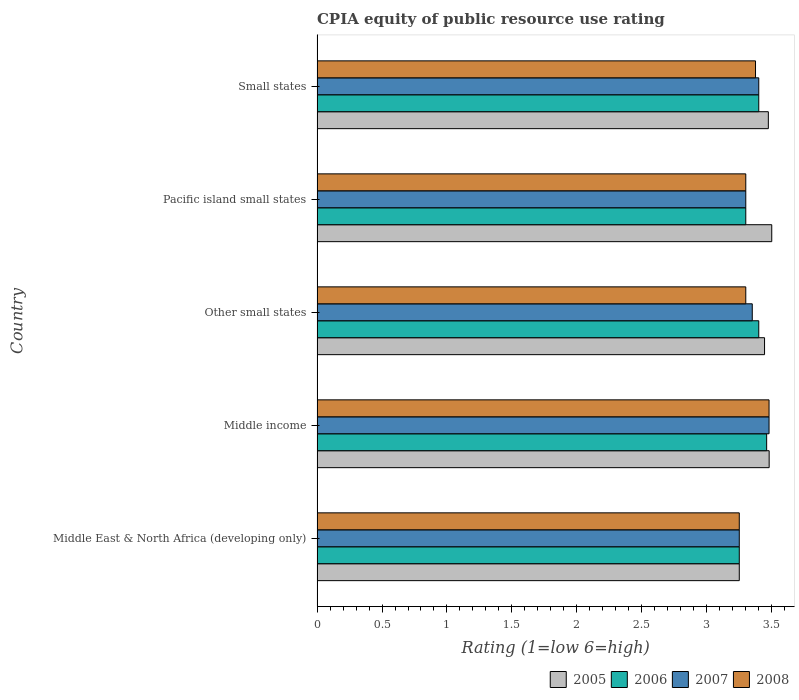Are the number of bars per tick equal to the number of legend labels?
Your answer should be compact. Yes. Are the number of bars on each tick of the Y-axis equal?
Offer a very short reply. Yes. What is the label of the 4th group of bars from the top?
Provide a short and direct response. Middle income. In how many cases, is the number of bars for a given country not equal to the number of legend labels?
Give a very brief answer. 0. What is the CPIA rating in 2007 in Small states?
Your answer should be very brief. 3.4. Across all countries, what is the maximum CPIA rating in 2007?
Provide a short and direct response. 3.48. In which country was the CPIA rating in 2005 maximum?
Your answer should be very brief. Pacific island small states. In which country was the CPIA rating in 2006 minimum?
Your answer should be very brief. Middle East & North Africa (developing only). What is the total CPIA rating in 2006 in the graph?
Give a very brief answer. 16.81. What is the difference between the CPIA rating in 2005 in Other small states and that in Small states?
Offer a very short reply. -0.03. What is the difference between the CPIA rating in 2008 in Pacific island small states and the CPIA rating in 2005 in Small states?
Give a very brief answer. -0.17. What is the average CPIA rating in 2005 per country?
Make the answer very short. 3.43. What is the difference between the CPIA rating in 2007 and CPIA rating in 2008 in Other small states?
Make the answer very short. 0.05. What is the ratio of the CPIA rating in 2007 in Middle income to that in Pacific island small states?
Keep it short and to the point. 1.05. What is the difference between the highest and the second highest CPIA rating in 2008?
Your answer should be very brief. 0.1. What is the difference between the highest and the lowest CPIA rating in 2008?
Offer a terse response. 0.23. Is it the case that in every country, the sum of the CPIA rating in 2008 and CPIA rating in 2007 is greater than the sum of CPIA rating in 2005 and CPIA rating in 2006?
Make the answer very short. No. What does the 4th bar from the bottom in Middle East & North Africa (developing only) represents?
Offer a very short reply. 2008. Is it the case that in every country, the sum of the CPIA rating in 2005 and CPIA rating in 2008 is greater than the CPIA rating in 2007?
Provide a succinct answer. Yes. Are all the bars in the graph horizontal?
Your response must be concise. Yes. How many countries are there in the graph?
Offer a very short reply. 5. Are the values on the major ticks of X-axis written in scientific E-notation?
Give a very brief answer. No. Does the graph contain grids?
Offer a very short reply. No. What is the title of the graph?
Keep it short and to the point. CPIA equity of public resource use rating. What is the label or title of the X-axis?
Keep it short and to the point. Rating (1=low 6=high). What is the Rating (1=low 6=high) of 2007 in Middle East & North Africa (developing only)?
Your answer should be compact. 3.25. What is the Rating (1=low 6=high) in 2005 in Middle income?
Give a very brief answer. 3.48. What is the Rating (1=low 6=high) of 2006 in Middle income?
Provide a short and direct response. 3.46. What is the Rating (1=low 6=high) of 2007 in Middle income?
Make the answer very short. 3.48. What is the Rating (1=low 6=high) in 2008 in Middle income?
Ensure brevity in your answer.  3.48. What is the Rating (1=low 6=high) in 2005 in Other small states?
Offer a terse response. 3.44. What is the Rating (1=low 6=high) in 2006 in Other small states?
Provide a short and direct response. 3.4. What is the Rating (1=low 6=high) in 2007 in Other small states?
Your answer should be very brief. 3.35. What is the Rating (1=low 6=high) in 2005 in Pacific island small states?
Your answer should be compact. 3.5. What is the Rating (1=low 6=high) of 2007 in Pacific island small states?
Your answer should be very brief. 3.3. What is the Rating (1=low 6=high) of 2008 in Pacific island small states?
Your response must be concise. 3.3. What is the Rating (1=low 6=high) of 2005 in Small states?
Provide a short and direct response. 3.47. What is the Rating (1=low 6=high) of 2006 in Small states?
Offer a very short reply. 3.4. What is the Rating (1=low 6=high) of 2008 in Small states?
Provide a succinct answer. 3.38. Across all countries, what is the maximum Rating (1=low 6=high) of 2006?
Your response must be concise. 3.46. Across all countries, what is the maximum Rating (1=low 6=high) in 2007?
Your answer should be compact. 3.48. Across all countries, what is the maximum Rating (1=low 6=high) of 2008?
Your answer should be compact. 3.48. Across all countries, what is the minimum Rating (1=low 6=high) of 2007?
Give a very brief answer. 3.25. Across all countries, what is the minimum Rating (1=low 6=high) in 2008?
Make the answer very short. 3.25. What is the total Rating (1=low 6=high) in 2005 in the graph?
Provide a succinct answer. 17.15. What is the total Rating (1=low 6=high) of 2006 in the graph?
Give a very brief answer. 16.81. What is the total Rating (1=low 6=high) of 2007 in the graph?
Ensure brevity in your answer.  16.78. What is the total Rating (1=low 6=high) of 2008 in the graph?
Ensure brevity in your answer.  16.7. What is the difference between the Rating (1=low 6=high) of 2005 in Middle East & North Africa (developing only) and that in Middle income?
Keep it short and to the point. -0.23. What is the difference between the Rating (1=low 6=high) of 2006 in Middle East & North Africa (developing only) and that in Middle income?
Keep it short and to the point. -0.21. What is the difference between the Rating (1=low 6=high) in 2007 in Middle East & North Africa (developing only) and that in Middle income?
Make the answer very short. -0.23. What is the difference between the Rating (1=low 6=high) of 2008 in Middle East & North Africa (developing only) and that in Middle income?
Make the answer very short. -0.23. What is the difference between the Rating (1=low 6=high) of 2005 in Middle East & North Africa (developing only) and that in Other small states?
Make the answer very short. -0.19. What is the difference between the Rating (1=low 6=high) of 2006 in Middle East & North Africa (developing only) and that in Other small states?
Make the answer very short. -0.15. What is the difference between the Rating (1=low 6=high) of 2008 in Middle East & North Africa (developing only) and that in Other small states?
Your response must be concise. -0.05. What is the difference between the Rating (1=low 6=high) in 2008 in Middle East & North Africa (developing only) and that in Pacific island small states?
Provide a short and direct response. -0.05. What is the difference between the Rating (1=low 6=high) of 2005 in Middle East & North Africa (developing only) and that in Small states?
Your response must be concise. -0.22. What is the difference between the Rating (1=low 6=high) in 2006 in Middle East & North Africa (developing only) and that in Small states?
Your answer should be very brief. -0.15. What is the difference between the Rating (1=low 6=high) of 2007 in Middle East & North Africa (developing only) and that in Small states?
Give a very brief answer. -0.15. What is the difference between the Rating (1=low 6=high) in 2008 in Middle East & North Africa (developing only) and that in Small states?
Provide a succinct answer. -0.12. What is the difference between the Rating (1=low 6=high) in 2005 in Middle income and that in Other small states?
Offer a terse response. 0.04. What is the difference between the Rating (1=low 6=high) of 2006 in Middle income and that in Other small states?
Make the answer very short. 0.06. What is the difference between the Rating (1=low 6=high) in 2007 in Middle income and that in Other small states?
Your answer should be very brief. 0.13. What is the difference between the Rating (1=low 6=high) in 2008 in Middle income and that in Other small states?
Keep it short and to the point. 0.18. What is the difference between the Rating (1=low 6=high) of 2005 in Middle income and that in Pacific island small states?
Your response must be concise. -0.02. What is the difference between the Rating (1=low 6=high) in 2006 in Middle income and that in Pacific island small states?
Your response must be concise. 0.16. What is the difference between the Rating (1=low 6=high) of 2007 in Middle income and that in Pacific island small states?
Give a very brief answer. 0.18. What is the difference between the Rating (1=low 6=high) of 2008 in Middle income and that in Pacific island small states?
Provide a short and direct response. 0.18. What is the difference between the Rating (1=low 6=high) in 2005 in Middle income and that in Small states?
Your answer should be compact. 0.01. What is the difference between the Rating (1=low 6=high) in 2006 in Middle income and that in Small states?
Provide a short and direct response. 0.06. What is the difference between the Rating (1=low 6=high) in 2007 in Middle income and that in Small states?
Your response must be concise. 0.08. What is the difference between the Rating (1=low 6=high) of 2008 in Middle income and that in Small states?
Your answer should be compact. 0.1. What is the difference between the Rating (1=low 6=high) of 2005 in Other small states and that in Pacific island small states?
Keep it short and to the point. -0.06. What is the difference between the Rating (1=low 6=high) of 2007 in Other small states and that in Pacific island small states?
Keep it short and to the point. 0.05. What is the difference between the Rating (1=low 6=high) in 2005 in Other small states and that in Small states?
Give a very brief answer. -0.03. What is the difference between the Rating (1=low 6=high) of 2006 in Other small states and that in Small states?
Keep it short and to the point. 0. What is the difference between the Rating (1=low 6=high) of 2008 in Other small states and that in Small states?
Keep it short and to the point. -0.07. What is the difference between the Rating (1=low 6=high) in 2005 in Pacific island small states and that in Small states?
Offer a very short reply. 0.03. What is the difference between the Rating (1=low 6=high) in 2006 in Pacific island small states and that in Small states?
Keep it short and to the point. -0.1. What is the difference between the Rating (1=low 6=high) of 2008 in Pacific island small states and that in Small states?
Offer a terse response. -0.07. What is the difference between the Rating (1=low 6=high) in 2005 in Middle East & North Africa (developing only) and the Rating (1=low 6=high) in 2006 in Middle income?
Provide a short and direct response. -0.21. What is the difference between the Rating (1=low 6=high) of 2005 in Middle East & North Africa (developing only) and the Rating (1=low 6=high) of 2007 in Middle income?
Provide a succinct answer. -0.23. What is the difference between the Rating (1=low 6=high) of 2005 in Middle East & North Africa (developing only) and the Rating (1=low 6=high) of 2008 in Middle income?
Your answer should be very brief. -0.23. What is the difference between the Rating (1=low 6=high) in 2006 in Middle East & North Africa (developing only) and the Rating (1=low 6=high) in 2007 in Middle income?
Your answer should be compact. -0.23. What is the difference between the Rating (1=low 6=high) of 2006 in Middle East & North Africa (developing only) and the Rating (1=low 6=high) of 2008 in Middle income?
Your answer should be compact. -0.23. What is the difference between the Rating (1=low 6=high) of 2007 in Middle East & North Africa (developing only) and the Rating (1=low 6=high) of 2008 in Middle income?
Your answer should be very brief. -0.23. What is the difference between the Rating (1=low 6=high) in 2005 in Middle East & North Africa (developing only) and the Rating (1=low 6=high) in 2007 in Other small states?
Give a very brief answer. -0.1. What is the difference between the Rating (1=low 6=high) of 2005 in Middle East & North Africa (developing only) and the Rating (1=low 6=high) of 2008 in Other small states?
Your response must be concise. -0.05. What is the difference between the Rating (1=low 6=high) of 2006 in Middle East & North Africa (developing only) and the Rating (1=low 6=high) of 2008 in Other small states?
Give a very brief answer. -0.05. What is the difference between the Rating (1=low 6=high) of 2007 in Middle East & North Africa (developing only) and the Rating (1=low 6=high) of 2008 in Other small states?
Your response must be concise. -0.05. What is the difference between the Rating (1=low 6=high) of 2006 in Middle East & North Africa (developing only) and the Rating (1=low 6=high) of 2007 in Pacific island small states?
Offer a very short reply. -0.05. What is the difference between the Rating (1=low 6=high) of 2007 in Middle East & North Africa (developing only) and the Rating (1=low 6=high) of 2008 in Pacific island small states?
Ensure brevity in your answer.  -0.05. What is the difference between the Rating (1=low 6=high) of 2005 in Middle East & North Africa (developing only) and the Rating (1=low 6=high) of 2008 in Small states?
Your response must be concise. -0.12. What is the difference between the Rating (1=low 6=high) in 2006 in Middle East & North Africa (developing only) and the Rating (1=low 6=high) in 2008 in Small states?
Provide a succinct answer. -0.12. What is the difference between the Rating (1=low 6=high) of 2007 in Middle East & North Africa (developing only) and the Rating (1=low 6=high) of 2008 in Small states?
Keep it short and to the point. -0.12. What is the difference between the Rating (1=low 6=high) in 2005 in Middle income and the Rating (1=low 6=high) in 2006 in Other small states?
Keep it short and to the point. 0.08. What is the difference between the Rating (1=low 6=high) of 2005 in Middle income and the Rating (1=low 6=high) of 2007 in Other small states?
Make the answer very short. 0.13. What is the difference between the Rating (1=low 6=high) in 2005 in Middle income and the Rating (1=low 6=high) in 2008 in Other small states?
Give a very brief answer. 0.18. What is the difference between the Rating (1=low 6=high) in 2006 in Middle income and the Rating (1=low 6=high) in 2007 in Other small states?
Provide a short and direct response. 0.11. What is the difference between the Rating (1=low 6=high) in 2006 in Middle income and the Rating (1=low 6=high) in 2008 in Other small states?
Your answer should be compact. 0.16. What is the difference between the Rating (1=low 6=high) of 2007 in Middle income and the Rating (1=low 6=high) of 2008 in Other small states?
Offer a terse response. 0.18. What is the difference between the Rating (1=low 6=high) of 2005 in Middle income and the Rating (1=low 6=high) of 2006 in Pacific island small states?
Ensure brevity in your answer.  0.18. What is the difference between the Rating (1=low 6=high) in 2005 in Middle income and the Rating (1=low 6=high) in 2007 in Pacific island small states?
Provide a succinct answer. 0.18. What is the difference between the Rating (1=low 6=high) of 2005 in Middle income and the Rating (1=low 6=high) of 2008 in Pacific island small states?
Give a very brief answer. 0.18. What is the difference between the Rating (1=low 6=high) in 2006 in Middle income and the Rating (1=low 6=high) in 2007 in Pacific island small states?
Ensure brevity in your answer.  0.16. What is the difference between the Rating (1=low 6=high) in 2006 in Middle income and the Rating (1=low 6=high) in 2008 in Pacific island small states?
Offer a very short reply. 0.16. What is the difference between the Rating (1=low 6=high) in 2007 in Middle income and the Rating (1=low 6=high) in 2008 in Pacific island small states?
Keep it short and to the point. 0.18. What is the difference between the Rating (1=low 6=high) in 2005 in Middle income and the Rating (1=low 6=high) in 2008 in Small states?
Give a very brief answer. 0.1. What is the difference between the Rating (1=low 6=high) in 2006 in Middle income and the Rating (1=low 6=high) in 2007 in Small states?
Offer a very short reply. 0.06. What is the difference between the Rating (1=low 6=high) of 2006 in Middle income and the Rating (1=low 6=high) of 2008 in Small states?
Your response must be concise. 0.09. What is the difference between the Rating (1=low 6=high) in 2007 in Middle income and the Rating (1=low 6=high) in 2008 in Small states?
Provide a short and direct response. 0.1. What is the difference between the Rating (1=low 6=high) in 2005 in Other small states and the Rating (1=low 6=high) in 2006 in Pacific island small states?
Your response must be concise. 0.14. What is the difference between the Rating (1=low 6=high) in 2005 in Other small states and the Rating (1=low 6=high) in 2007 in Pacific island small states?
Provide a succinct answer. 0.14. What is the difference between the Rating (1=low 6=high) of 2005 in Other small states and the Rating (1=low 6=high) of 2008 in Pacific island small states?
Make the answer very short. 0.14. What is the difference between the Rating (1=low 6=high) in 2006 in Other small states and the Rating (1=low 6=high) in 2008 in Pacific island small states?
Your response must be concise. 0.1. What is the difference between the Rating (1=low 6=high) of 2005 in Other small states and the Rating (1=low 6=high) of 2006 in Small states?
Give a very brief answer. 0.04. What is the difference between the Rating (1=low 6=high) of 2005 in Other small states and the Rating (1=low 6=high) of 2007 in Small states?
Ensure brevity in your answer.  0.04. What is the difference between the Rating (1=low 6=high) of 2005 in Other small states and the Rating (1=low 6=high) of 2008 in Small states?
Offer a very short reply. 0.07. What is the difference between the Rating (1=low 6=high) of 2006 in Other small states and the Rating (1=low 6=high) of 2008 in Small states?
Give a very brief answer. 0.03. What is the difference between the Rating (1=low 6=high) in 2007 in Other small states and the Rating (1=low 6=high) in 2008 in Small states?
Your response must be concise. -0.03. What is the difference between the Rating (1=low 6=high) of 2006 in Pacific island small states and the Rating (1=low 6=high) of 2007 in Small states?
Your answer should be compact. -0.1. What is the difference between the Rating (1=low 6=high) of 2006 in Pacific island small states and the Rating (1=low 6=high) of 2008 in Small states?
Provide a short and direct response. -0.07. What is the difference between the Rating (1=low 6=high) of 2007 in Pacific island small states and the Rating (1=low 6=high) of 2008 in Small states?
Offer a terse response. -0.07. What is the average Rating (1=low 6=high) of 2005 per country?
Ensure brevity in your answer.  3.43. What is the average Rating (1=low 6=high) of 2006 per country?
Offer a very short reply. 3.36. What is the average Rating (1=low 6=high) in 2007 per country?
Offer a very short reply. 3.36. What is the average Rating (1=low 6=high) of 2008 per country?
Provide a short and direct response. 3.34. What is the difference between the Rating (1=low 6=high) in 2005 and Rating (1=low 6=high) in 2007 in Middle East & North Africa (developing only)?
Your answer should be compact. 0. What is the difference between the Rating (1=low 6=high) of 2006 and Rating (1=low 6=high) of 2007 in Middle East & North Africa (developing only)?
Your answer should be compact. 0. What is the difference between the Rating (1=low 6=high) of 2006 and Rating (1=low 6=high) of 2008 in Middle East & North Africa (developing only)?
Your response must be concise. 0. What is the difference between the Rating (1=low 6=high) in 2005 and Rating (1=low 6=high) in 2006 in Middle income?
Make the answer very short. 0.02. What is the difference between the Rating (1=low 6=high) of 2005 and Rating (1=low 6=high) of 2007 in Middle income?
Provide a short and direct response. 0. What is the difference between the Rating (1=low 6=high) in 2005 and Rating (1=low 6=high) in 2008 in Middle income?
Offer a terse response. 0. What is the difference between the Rating (1=low 6=high) in 2006 and Rating (1=low 6=high) in 2007 in Middle income?
Provide a succinct answer. -0.02. What is the difference between the Rating (1=low 6=high) in 2006 and Rating (1=low 6=high) in 2008 in Middle income?
Provide a short and direct response. -0.02. What is the difference between the Rating (1=low 6=high) in 2007 and Rating (1=low 6=high) in 2008 in Middle income?
Provide a succinct answer. 0. What is the difference between the Rating (1=low 6=high) in 2005 and Rating (1=low 6=high) in 2006 in Other small states?
Offer a very short reply. 0.04. What is the difference between the Rating (1=low 6=high) in 2005 and Rating (1=low 6=high) in 2007 in Other small states?
Your answer should be very brief. 0.09. What is the difference between the Rating (1=low 6=high) in 2005 and Rating (1=low 6=high) in 2008 in Other small states?
Your response must be concise. 0.14. What is the difference between the Rating (1=low 6=high) in 2006 and Rating (1=low 6=high) in 2007 in Other small states?
Keep it short and to the point. 0.05. What is the difference between the Rating (1=low 6=high) of 2005 and Rating (1=low 6=high) of 2007 in Pacific island small states?
Make the answer very short. 0.2. What is the difference between the Rating (1=low 6=high) of 2005 and Rating (1=low 6=high) of 2008 in Pacific island small states?
Keep it short and to the point. 0.2. What is the difference between the Rating (1=low 6=high) in 2007 and Rating (1=low 6=high) in 2008 in Pacific island small states?
Offer a very short reply. 0. What is the difference between the Rating (1=low 6=high) in 2005 and Rating (1=low 6=high) in 2006 in Small states?
Give a very brief answer. 0.07. What is the difference between the Rating (1=low 6=high) of 2005 and Rating (1=low 6=high) of 2007 in Small states?
Give a very brief answer. 0.07. What is the difference between the Rating (1=low 6=high) of 2005 and Rating (1=low 6=high) of 2008 in Small states?
Ensure brevity in your answer.  0.1. What is the difference between the Rating (1=low 6=high) of 2006 and Rating (1=low 6=high) of 2008 in Small states?
Offer a very short reply. 0.03. What is the difference between the Rating (1=low 6=high) in 2007 and Rating (1=low 6=high) in 2008 in Small states?
Ensure brevity in your answer.  0.03. What is the ratio of the Rating (1=low 6=high) of 2005 in Middle East & North Africa (developing only) to that in Middle income?
Offer a very short reply. 0.93. What is the ratio of the Rating (1=low 6=high) of 2006 in Middle East & North Africa (developing only) to that in Middle income?
Your response must be concise. 0.94. What is the ratio of the Rating (1=low 6=high) in 2007 in Middle East & North Africa (developing only) to that in Middle income?
Give a very brief answer. 0.93. What is the ratio of the Rating (1=low 6=high) in 2008 in Middle East & North Africa (developing only) to that in Middle income?
Offer a terse response. 0.93. What is the ratio of the Rating (1=low 6=high) of 2005 in Middle East & North Africa (developing only) to that in Other small states?
Ensure brevity in your answer.  0.94. What is the ratio of the Rating (1=low 6=high) in 2006 in Middle East & North Africa (developing only) to that in Other small states?
Your answer should be very brief. 0.96. What is the ratio of the Rating (1=low 6=high) of 2007 in Middle East & North Africa (developing only) to that in Other small states?
Make the answer very short. 0.97. What is the ratio of the Rating (1=low 6=high) of 2008 in Middle East & North Africa (developing only) to that in Other small states?
Your answer should be very brief. 0.98. What is the ratio of the Rating (1=low 6=high) in 2005 in Middle East & North Africa (developing only) to that in Pacific island small states?
Give a very brief answer. 0.93. What is the ratio of the Rating (1=low 6=high) in 2007 in Middle East & North Africa (developing only) to that in Pacific island small states?
Offer a terse response. 0.98. What is the ratio of the Rating (1=low 6=high) of 2008 in Middle East & North Africa (developing only) to that in Pacific island small states?
Offer a terse response. 0.98. What is the ratio of the Rating (1=low 6=high) of 2005 in Middle East & North Africa (developing only) to that in Small states?
Keep it short and to the point. 0.94. What is the ratio of the Rating (1=low 6=high) of 2006 in Middle East & North Africa (developing only) to that in Small states?
Offer a terse response. 0.96. What is the ratio of the Rating (1=low 6=high) of 2007 in Middle East & North Africa (developing only) to that in Small states?
Make the answer very short. 0.96. What is the ratio of the Rating (1=low 6=high) of 2008 in Middle East & North Africa (developing only) to that in Small states?
Your answer should be compact. 0.96. What is the ratio of the Rating (1=low 6=high) in 2005 in Middle income to that in Other small states?
Ensure brevity in your answer.  1.01. What is the ratio of the Rating (1=low 6=high) in 2006 in Middle income to that in Other small states?
Offer a terse response. 1.02. What is the ratio of the Rating (1=low 6=high) of 2007 in Middle income to that in Other small states?
Keep it short and to the point. 1.04. What is the ratio of the Rating (1=low 6=high) of 2008 in Middle income to that in Other small states?
Provide a short and direct response. 1.05. What is the ratio of the Rating (1=low 6=high) in 2005 in Middle income to that in Pacific island small states?
Give a very brief answer. 0.99. What is the ratio of the Rating (1=low 6=high) of 2006 in Middle income to that in Pacific island small states?
Give a very brief answer. 1.05. What is the ratio of the Rating (1=low 6=high) of 2007 in Middle income to that in Pacific island small states?
Your answer should be compact. 1.05. What is the ratio of the Rating (1=low 6=high) in 2008 in Middle income to that in Pacific island small states?
Keep it short and to the point. 1.05. What is the ratio of the Rating (1=low 6=high) in 2005 in Middle income to that in Small states?
Provide a succinct answer. 1. What is the ratio of the Rating (1=low 6=high) in 2006 in Middle income to that in Small states?
Provide a succinct answer. 1.02. What is the ratio of the Rating (1=low 6=high) of 2007 in Middle income to that in Small states?
Offer a very short reply. 1.02. What is the ratio of the Rating (1=low 6=high) of 2008 in Middle income to that in Small states?
Ensure brevity in your answer.  1.03. What is the ratio of the Rating (1=low 6=high) of 2005 in Other small states to that in Pacific island small states?
Ensure brevity in your answer.  0.98. What is the ratio of the Rating (1=low 6=high) in 2006 in Other small states to that in Pacific island small states?
Provide a succinct answer. 1.03. What is the ratio of the Rating (1=low 6=high) in 2007 in Other small states to that in Pacific island small states?
Keep it short and to the point. 1.02. What is the ratio of the Rating (1=low 6=high) of 2008 in Other small states to that in Pacific island small states?
Keep it short and to the point. 1. What is the ratio of the Rating (1=low 6=high) of 2008 in Other small states to that in Small states?
Offer a terse response. 0.98. What is the ratio of the Rating (1=low 6=high) in 2005 in Pacific island small states to that in Small states?
Offer a terse response. 1.01. What is the ratio of the Rating (1=low 6=high) of 2006 in Pacific island small states to that in Small states?
Your answer should be very brief. 0.97. What is the ratio of the Rating (1=low 6=high) in 2007 in Pacific island small states to that in Small states?
Make the answer very short. 0.97. What is the ratio of the Rating (1=low 6=high) in 2008 in Pacific island small states to that in Small states?
Make the answer very short. 0.98. What is the difference between the highest and the second highest Rating (1=low 6=high) in 2005?
Provide a succinct answer. 0.02. What is the difference between the highest and the second highest Rating (1=low 6=high) in 2006?
Keep it short and to the point. 0.06. What is the difference between the highest and the second highest Rating (1=low 6=high) of 2007?
Offer a very short reply. 0.08. What is the difference between the highest and the second highest Rating (1=low 6=high) in 2008?
Your response must be concise. 0.1. What is the difference between the highest and the lowest Rating (1=low 6=high) in 2006?
Offer a very short reply. 0.21. What is the difference between the highest and the lowest Rating (1=low 6=high) of 2007?
Keep it short and to the point. 0.23. What is the difference between the highest and the lowest Rating (1=low 6=high) in 2008?
Offer a very short reply. 0.23. 